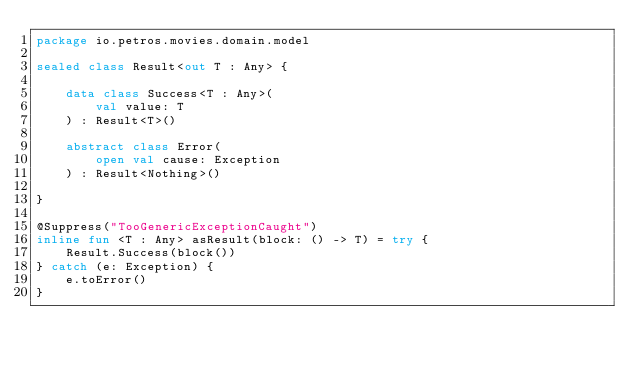<code> <loc_0><loc_0><loc_500><loc_500><_Kotlin_>package io.petros.movies.domain.model

sealed class Result<out T : Any> {

    data class Success<T : Any>(
        val value: T
    ) : Result<T>()

    abstract class Error(
        open val cause: Exception
    ) : Result<Nothing>()

}

@Suppress("TooGenericExceptionCaught")
inline fun <T : Any> asResult(block: () -> T) = try {
    Result.Success(block())
} catch (e: Exception) {
    e.toError()
}
</code> 